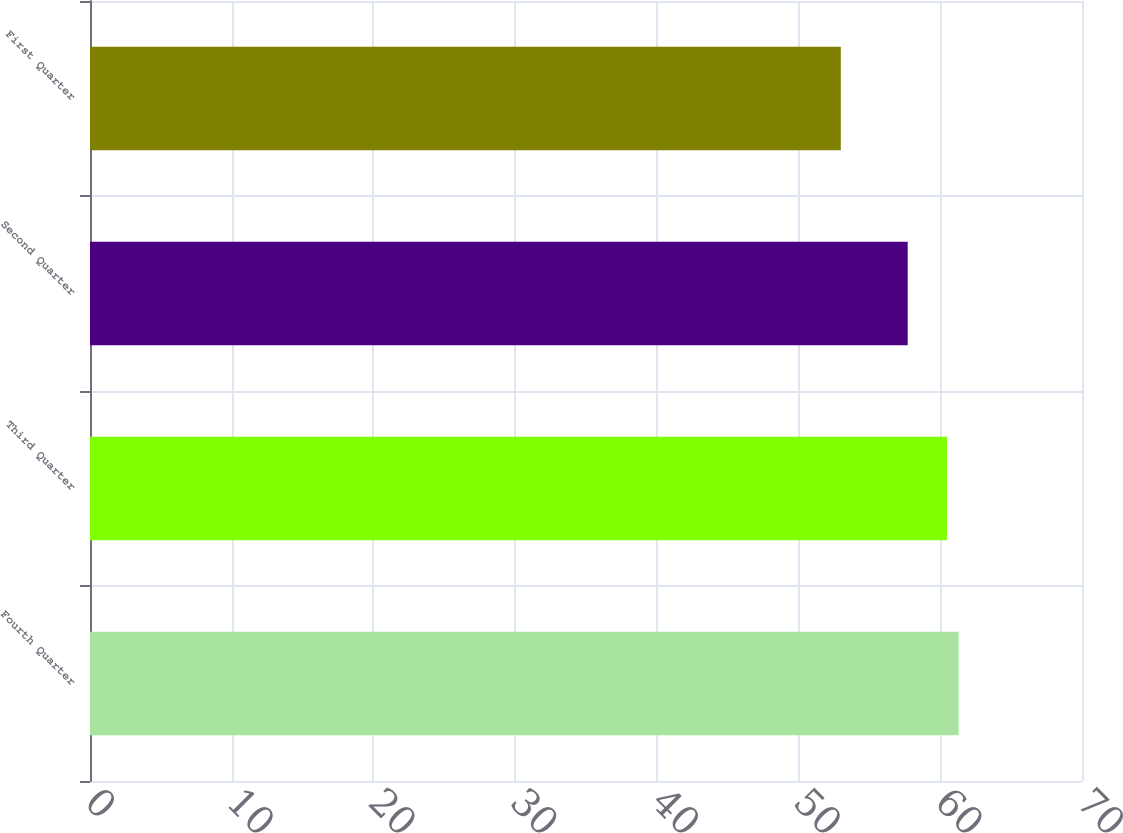Convert chart to OTSL. <chart><loc_0><loc_0><loc_500><loc_500><bar_chart><fcel>Fourth Quarter<fcel>Third Quarter<fcel>Second Quarter<fcel>First Quarter<nl><fcel>61.3<fcel>60.47<fcel>57.7<fcel>52.98<nl></chart> 